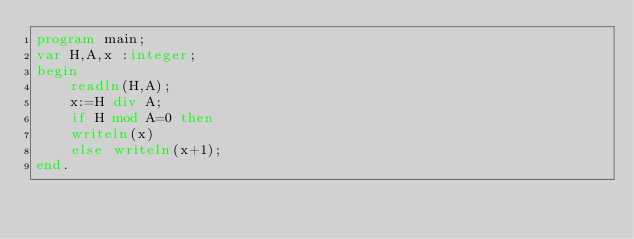<code> <loc_0><loc_0><loc_500><loc_500><_Pascal_>program main;
var H,A,x :integer;
begin
    readln(H,A);
    x:=H div A;
    if H mod A=0 then 
    writeln(x)
    else writeln(x+1);
end.</code> 